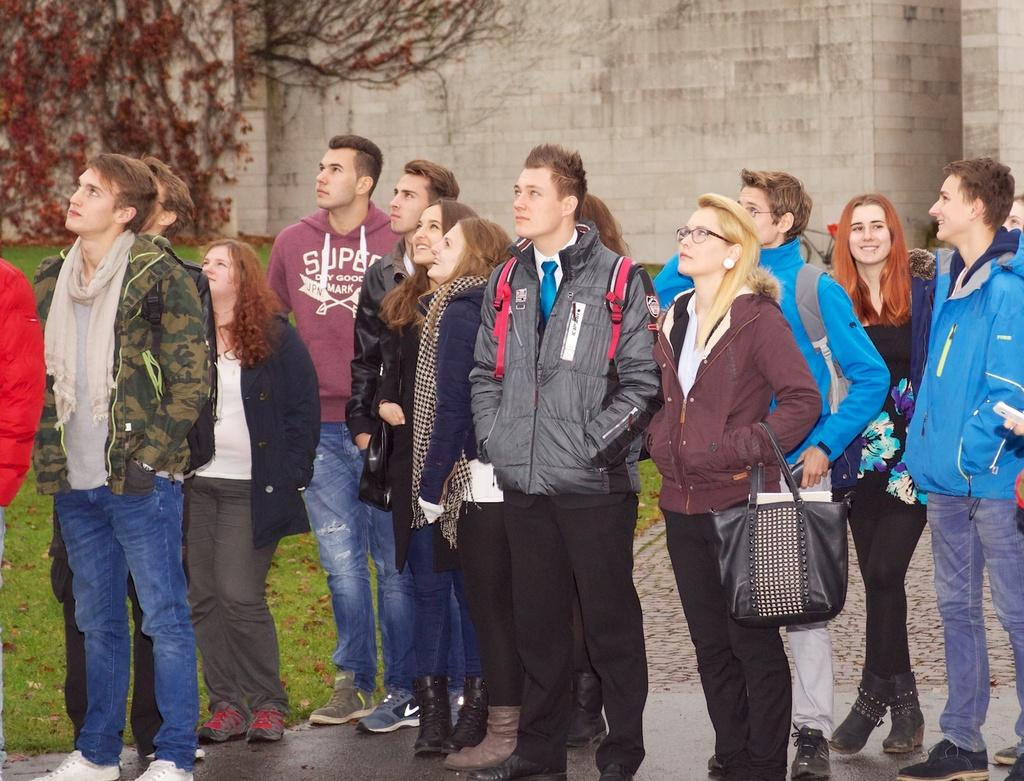How many people can be seen in the image? There are many people standing in the image. Can you describe the lady in the image? The lady is wearing specs and holding a bag. What can be seen in the background of the image? There is a wall with creepers in the background. What type of ground is visible in the image? There is grass on the ground. How does the lady maintain her balance during the earthquake in the image? There is no earthquake present in the image, so the lady does not need to maintain her balance due to one. 